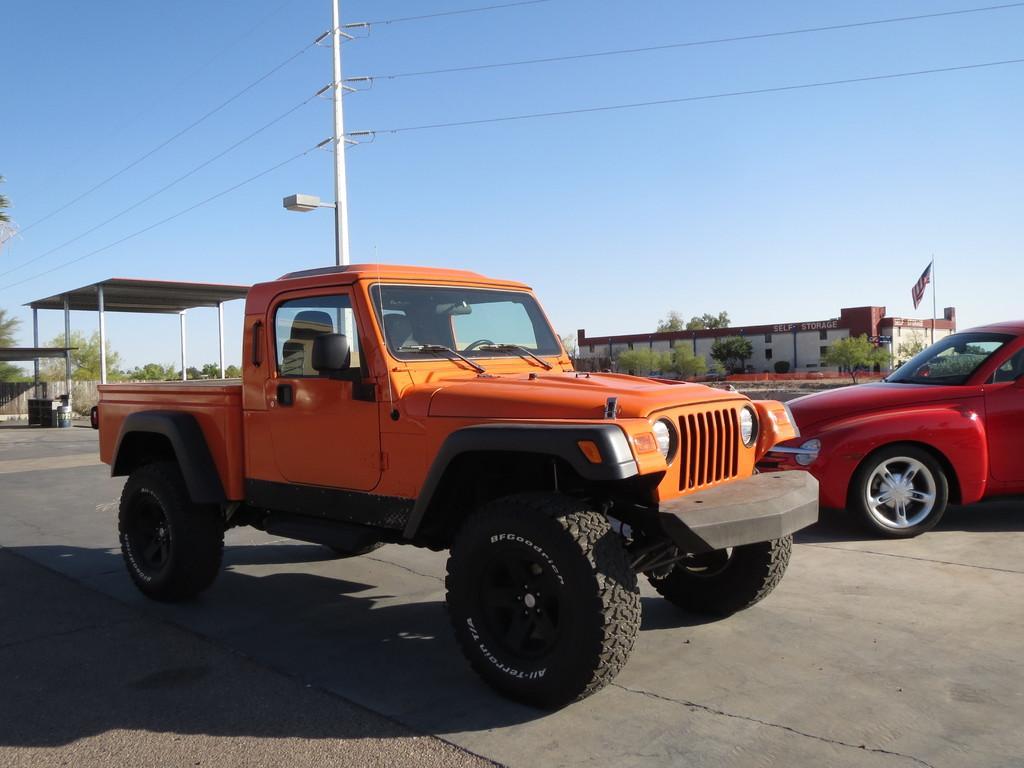Describe this image in one or two sentences. In the image there is a jeep and a car on the road, in the back there are buildings and electric poles and above its sky. 